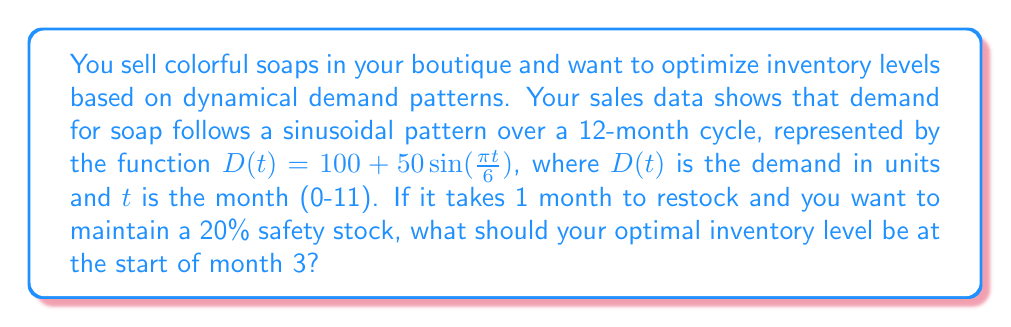Give your solution to this math problem. 1. Understand the demand function:
   $D(t) = 100 + 50\sin(\frac{\pi t}{6})$

2. Calculate the demand for month 3 (t = 3):
   $D(3) = 100 + 50\sin(\frac{\pi \cdot 3}{6}) = 100 + 50\sin(\frac{\pi}{2}) = 100 + 50 = 150$ units

3. Calculate the demand for month 4 (t = 4), as it takes 1 month to restock:
   $D(4) = 100 + 50\sin(\frac{\pi \cdot 4}{6}) = 100 + 50\sin(\frac{2\pi}{3}) = 100 + 50 \cdot \frac{\sqrt{3}}{2} \approx 143.3$ units

4. Take the maximum of these two months:
   $\max(D(3), D(4)) = 150$ units

5. Add 20% safety stock:
   $150 \cdot 1.2 = 180$ units

Therefore, the optimal inventory level at the start of month 3 should be 180 units.
Answer: 180 units 